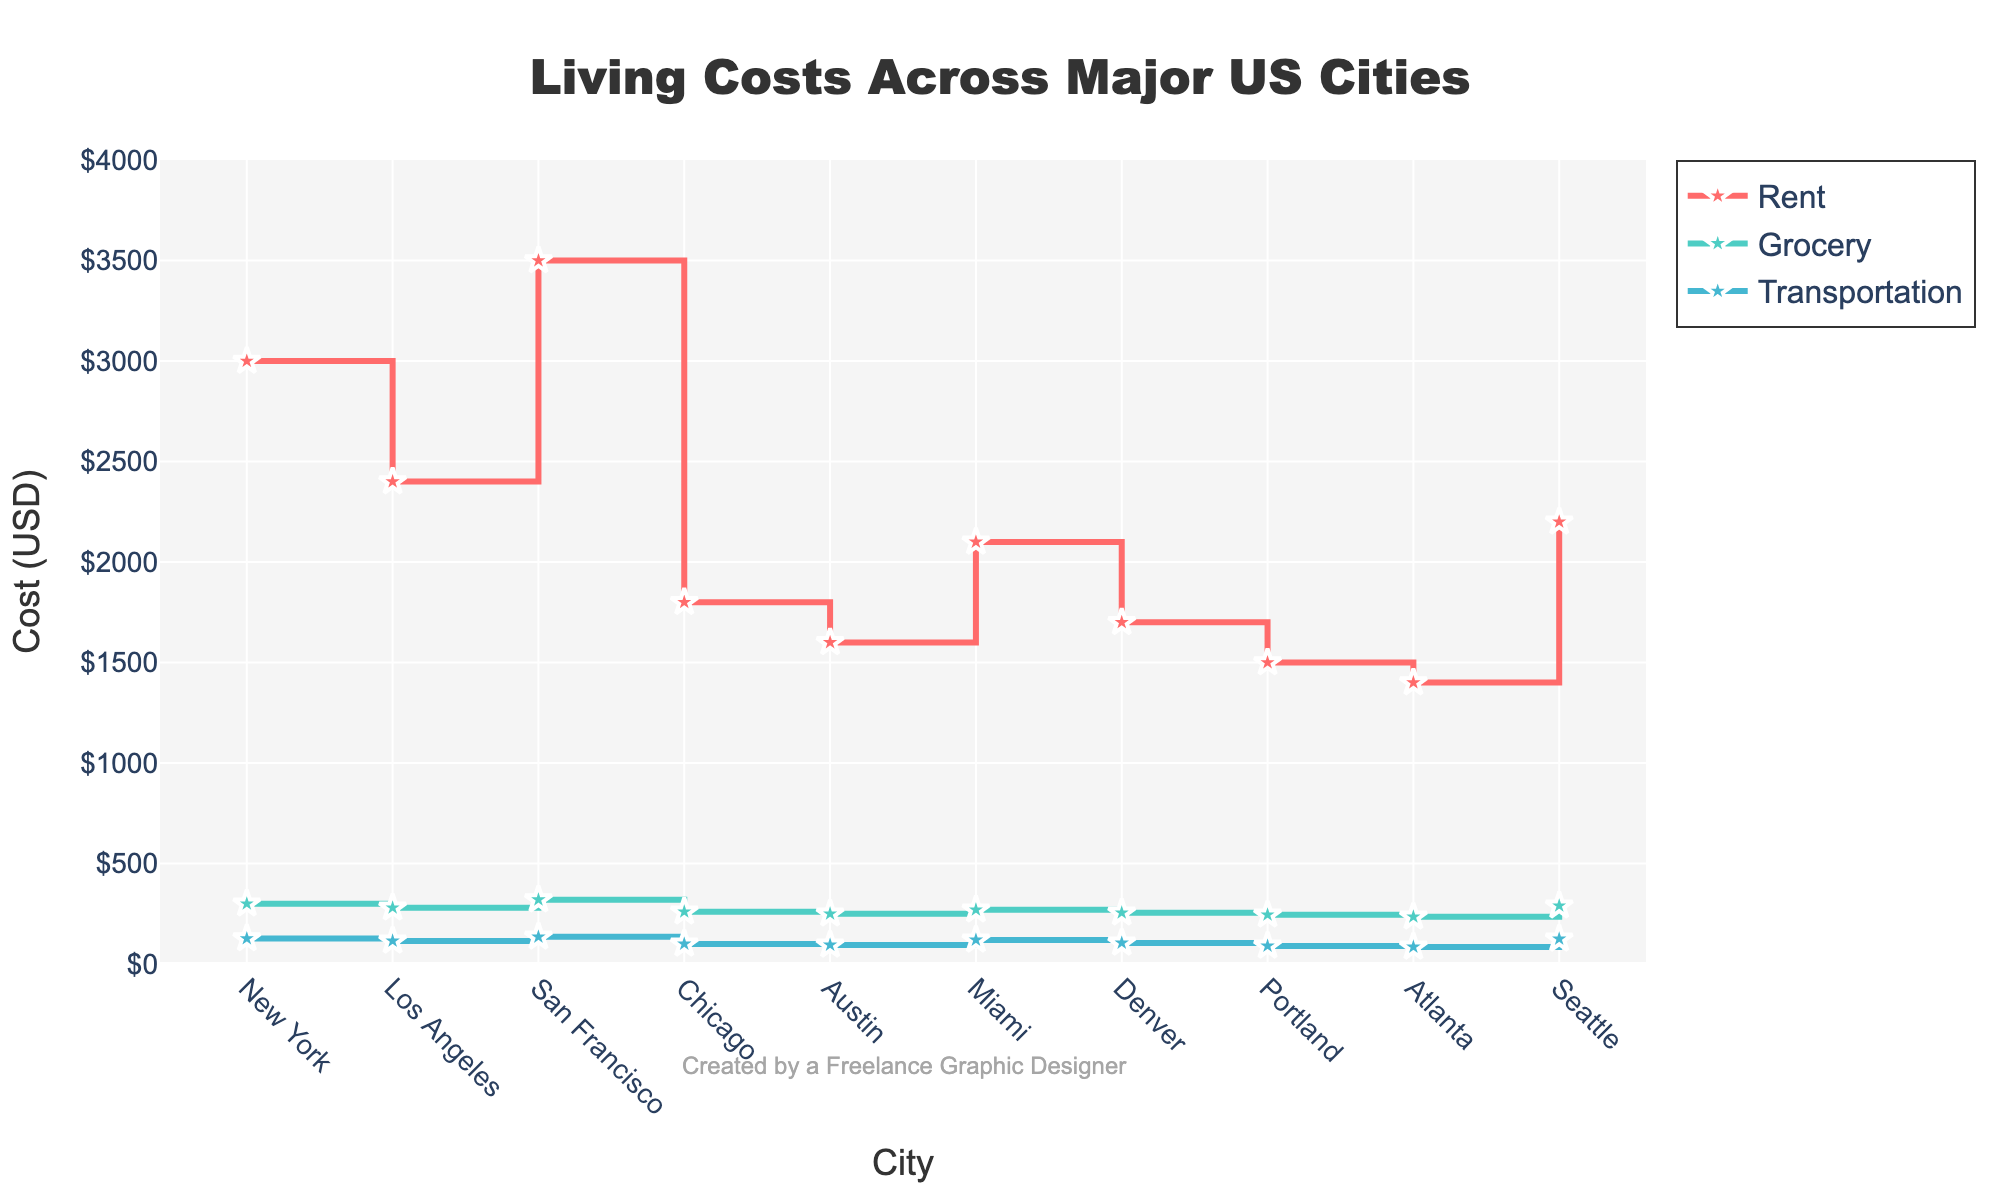What is the title of the figure? The title is located at the top center of the figure, and it states the main subject of the plot.
Answer: Living Costs Across Major US Cities Which city has the highest rent? By looking at the rent trace in the figure, the city with the highest point on the vertical axis for rent can be identified.
Answer: San Francisco How much more expensive are groceries in New York compared to Austin? First, note the grocery costs for New York ($300) and Austin ($250). Then, subtract the cost in Austin from the cost in New York: $300 - $250.
Answer: $50 Which city has the lowest transportation cost? Find the lowest point along the transportation trace in the figure and identify which city it corresponds to.
Answer: Portland Compare the rent costs between Los Angeles and Chicago and determine the percentage difference. Note the rent costs: Los Angeles ($2400) and Chicago ($1800). The difference is $2400 - $1800 = $600. The percentage difference is calculated by (600 / 2400) * 100.
Answer: 25% What is the combined cost of rent, groceries, and transportation in Portland? Identify the costs for rent ($1500), groceries ($245), and transportation ($90) in Portland and sum them up: $1500 + $245 + $90.
Answer: $1835 On average, which expense category has the highest cost across all cities? Calculate the sum of each category (Rent, Grocery, Transportation) across all cities and then divide each by the number of cities (10). Compare the averages to determine the highest.
Answer: Rent Is the transportation cost in Miami higher or lower than in Denver? Note the transportation costs for Miami ($120) and Denver ($105). Compare the values to determine the relationship.
Answer: Higher Which city has the smallest gap between grocery and transportation costs? For each city, calculate the absolute difference between grocery and transportation costs and identify the city with the smallest difference.
Answer: Portland Rank the cities from highest to lowest in terms of rent costs. List the cities in descending order according to their rent costs as depicted in the figure.
Answer: San Francisco, New York, Los Angeles, Seattle, Miami, Chicago, Denver, Austin, Portland, Atlanta 